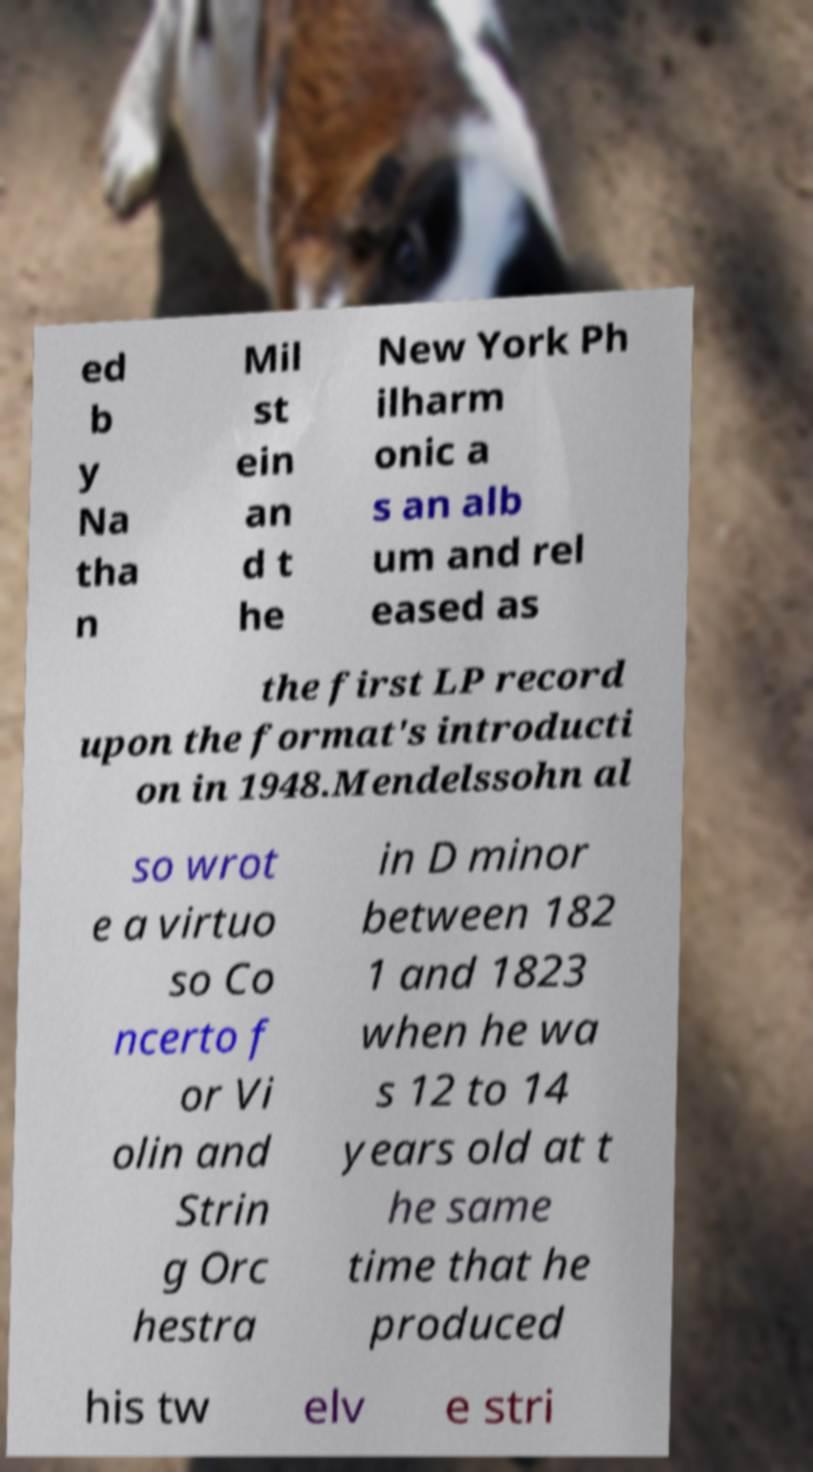What messages or text are displayed in this image? I need them in a readable, typed format. ed b y Na tha n Mil st ein an d t he New York Ph ilharm onic a s an alb um and rel eased as the first LP record upon the format's introducti on in 1948.Mendelssohn al so wrot e a virtuo so Co ncerto f or Vi olin and Strin g Orc hestra in D minor between 182 1 and 1823 when he wa s 12 to 14 years old at t he same time that he produced his tw elv e stri 